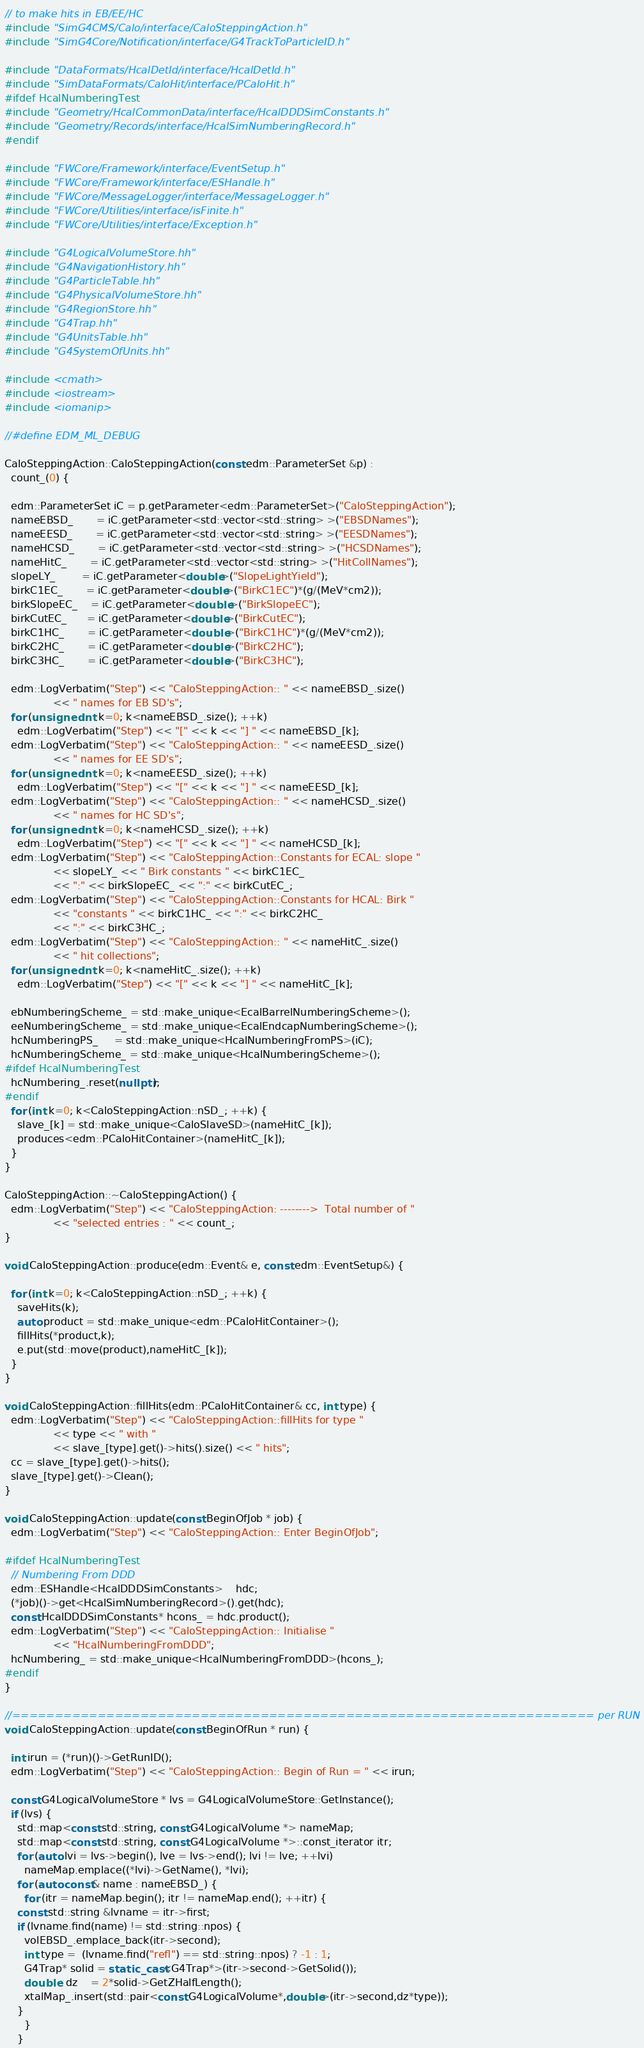Convert code to text. <code><loc_0><loc_0><loc_500><loc_500><_C++_>// to make hits in EB/EE/HC
#include "SimG4CMS/Calo/interface/CaloSteppingAction.h"
#include "SimG4Core/Notification/interface/G4TrackToParticleID.h"

#include "DataFormats/HcalDetId/interface/HcalDetId.h"
#include "SimDataFormats/CaloHit/interface/PCaloHit.h"
#ifdef HcalNumberingTest
#include "Geometry/HcalCommonData/interface/HcalDDDSimConstants.h"
#include "Geometry/Records/interface/HcalSimNumberingRecord.h"
#endif

#include "FWCore/Framework/interface/EventSetup.h"
#include "FWCore/Framework/interface/ESHandle.h"
#include "FWCore/MessageLogger/interface/MessageLogger.h"
#include "FWCore/Utilities/interface/isFinite.h"
#include "FWCore/Utilities/interface/Exception.h"

#include "G4LogicalVolumeStore.hh"
#include "G4NavigationHistory.hh"
#include "G4ParticleTable.hh"
#include "G4PhysicalVolumeStore.hh"
#include "G4RegionStore.hh"
#include "G4Trap.hh"
#include "G4UnitsTable.hh"
#include "G4SystemOfUnits.hh"

#include <cmath>
#include <iostream>
#include <iomanip>

//#define EDM_ML_DEBUG

CaloSteppingAction::CaloSteppingAction(const edm::ParameterSet &p) : 
  count_(0) {

  edm::ParameterSet iC = p.getParameter<edm::ParameterSet>("CaloSteppingAction");
  nameEBSD_       = iC.getParameter<std::vector<std::string> >("EBSDNames");
  nameEESD_       = iC.getParameter<std::vector<std::string> >("EESDNames");
  nameHCSD_       = iC.getParameter<std::vector<std::string> >("HCSDNames");
  nameHitC_       = iC.getParameter<std::vector<std::string> >("HitCollNames");
  slopeLY_        = iC.getParameter<double>("SlopeLightYield");
  birkC1EC_       = iC.getParameter<double>("BirkC1EC")*(g/(MeV*cm2));
  birkSlopeEC_    = iC.getParameter<double>("BirkSlopeEC");
  birkCutEC_      = iC.getParameter<double>("BirkCutEC");
  birkC1HC_       = iC.getParameter<double>("BirkC1HC")*(g/(MeV*cm2));
  birkC2HC_       = iC.getParameter<double>("BirkC2HC");
  birkC3HC_       = iC.getParameter<double>("BirkC3HC");

  edm::LogVerbatim("Step") << "CaloSteppingAction:: " << nameEBSD_.size() 
			   << " names for EB SD's";
  for (unsigned int k=0; k<nameEBSD_.size(); ++k)
    edm::LogVerbatim("Step") << "[" << k << "] " << nameEBSD_[k];
  edm::LogVerbatim("Step") << "CaloSteppingAction:: " << nameEESD_.size() 
			   << " names for EE SD's";
  for (unsigned int k=0; k<nameEESD_.size(); ++k)
    edm::LogVerbatim("Step") << "[" << k << "] " << nameEESD_[k];
  edm::LogVerbatim("Step") << "CaloSteppingAction:: " << nameHCSD_.size() 
			   << " names for HC SD's";
  for (unsigned int k=0; k<nameHCSD_.size(); ++k)
    edm::LogVerbatim("Step") << "[" << k << "] " << nameHCSD_[k];
  edm::LogVerbatim("Step") << "CaloSteppingAction::Constants for ECAL: slope "
			   << slopeLY_ << " Birk constants " << birkC1EC_ 
			   << ":" << birkSlopeEC_ << ":" << birkCutEC_;
  edm::LogVerbatim("Step") << "CaloSteppingAction::Constants for HCAL: Birk "
			   << "constants " << birkC1HC_ << ":" << birkC2HC_
			   << ":" << birkC3HC_;
  edm::LogVerbatim("Step") << "CaloSteppingAction:: " << nameHitC_.size() 
			   << " hit collections";
  for (unsigned int k=0; k<nameHitC_.size(); ++k)
    edm::LogVerbatim("Step") << "[" << k << "] " << nameHitC_[k];

  ebNumberingScheme_ = std::make_unique<EcalBarrelNumberingScheme>();
  eeNumberingScheme_ = std::make_unique<EcalEndcapNumberingScheme>();
  hcNumberingPS_     = std::make_unique<HcalNumberingFromPS>(iC);
  hcNumberingScheme_ = std::make_unique<HcalNumberingScheme>();
#ifdef HcalNumberingTest
  hcNumbering_.reset(nullptr);
#endif
  for (int k=0; k<CaloSteppingAction::nSD_; ++k) {
    slave_[k] = std::make_unique<CaloSlaveSD>(nameHitC_[k]);
    produces<edm::PCaloHitContainer>(nameHitC_[k]);
  }
} 
   
CaloSteppingAction::~CaloSteppingAction() {
  edm::LogVerbatim("Step") << "CaloSteppingAction: -------->  Total number of "
			   << "selected entries : " << count_;
}

void CaloSteppingAction::produce(edm::Event& e, const edm::EventSetup&) {

  for (int k=0; k<CaloSteppingAction::nSD_; ++k) {
    saveHits(k);
    auto product = std::make_unique<edm::PCaloHitContainer>();
    fillHits(*product,k);
    e.put(std::move(product),nameHitC_[k]);
  }
}

void CaloSteppingAction::fillHits(edm::PCaloHitContainer& cc, int type) {
  edm::LogVerbatim("Step") << "CaloSteppingAction::fillHits for type "
			   << type << " with "
			   << slave_[type].get()->hits().size() << " hits";
  cc = slave_[type].get()->hits();
  slave_[type].get()->Clean();
}

void CaloSteppingAction::update(const BeginOfJob * job) {
  edm::LogVerbatim("Step") << "CaloSteppingAction:: Enter BeginOfJob";

#ifdef HcalNumberingTest
  // Numbering From DDD
  edm::ESHandle<HcalDDDSimConstants>    hdc;
  (*job)()->get<HcalSimNumberingRecord>().get(hdc);
  const HcalDDDSimConstants* hcons_ = hdc.product();
  edm::LogVerbatim("Step") << "CaloSteppingAction:: Initialise "
			   << "HcalNumberingFromDDD";
  hcNumbering_ = std::make_unique<HcalNumberingFromDDD>(hcons_);
#endif
}

//==================================================================== per RUN
void CaloSteppingAction::update(const BeginOfRun * run) {

  int irun = (*run)()->GetRunID();
  edm::LogVerbatim("Step") << "CaloSteppingAction:: Begin of Run = " << irun;

  const G4LogicalVolumeStore * lvs = G4LogicalVolumeStore::GetInstance();
  if (lvs) {
    std::map<const std::string, const G4LogicalVolume *> nameMap;
    std::map<const std::string, const G4LogicalVolume *>::const_iterator itr;
    for (auto lvi = lvs->begin(), lve = lvs->end(); lvi != lve; ++lvi)
      nameMap.emplace((*lvi)->GetName(), *lvi);
    for (auto const& name : nameEBSD_) {
      for (itr = nameMap.begin(); itr != nameMap.end(); ++itr) {
	const std::string &lvname = itr->first;
	if (lvname.find(name) != std::string::npos) {
	  volEBSD_.emplace_back(itr->second);
	  int type =  (lvname.find("refl") == std::string::npos) ? -1 : 1;
	  G4Trap* solid = static_cast<G4Trap*>(itr->second->GetSolid());
	  double  dz    = 2*solid->GetZHalfLength();
	  xtalMap_.insert(std::pair<const G4LogicalVolume*,double>(itr->second,dz*type));
	}
      }
    }</code> 